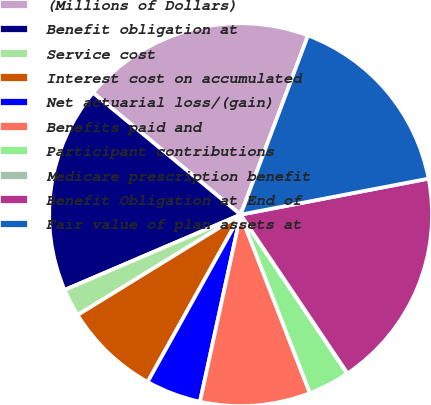Convert chart. <chart><loc_0><loc_0><loc_500><loc_500><pie_chart><fcel>(Millions of Dollars)<fcel>Benefit obligation at<fcel>Service cost<fcel>Interest cost on accumulated<fcel>Net actuarial loss/(gain)<fcel>Benefits paid and<fcel>Participant contributions<fcel>Medicare prescription benefit<fcel>Benefit Obligation at End of<fcel>Fair value of plan assets at<nl><fcel>19.74%<fcel>17.42%<fcel>2.35%<fcel>8.14%<fcel>4.67%<fcel>9.3%<fcel>3.51%<fcel>0.03%<fcel>18.58%<fcel>16.26%<nl></chart> 